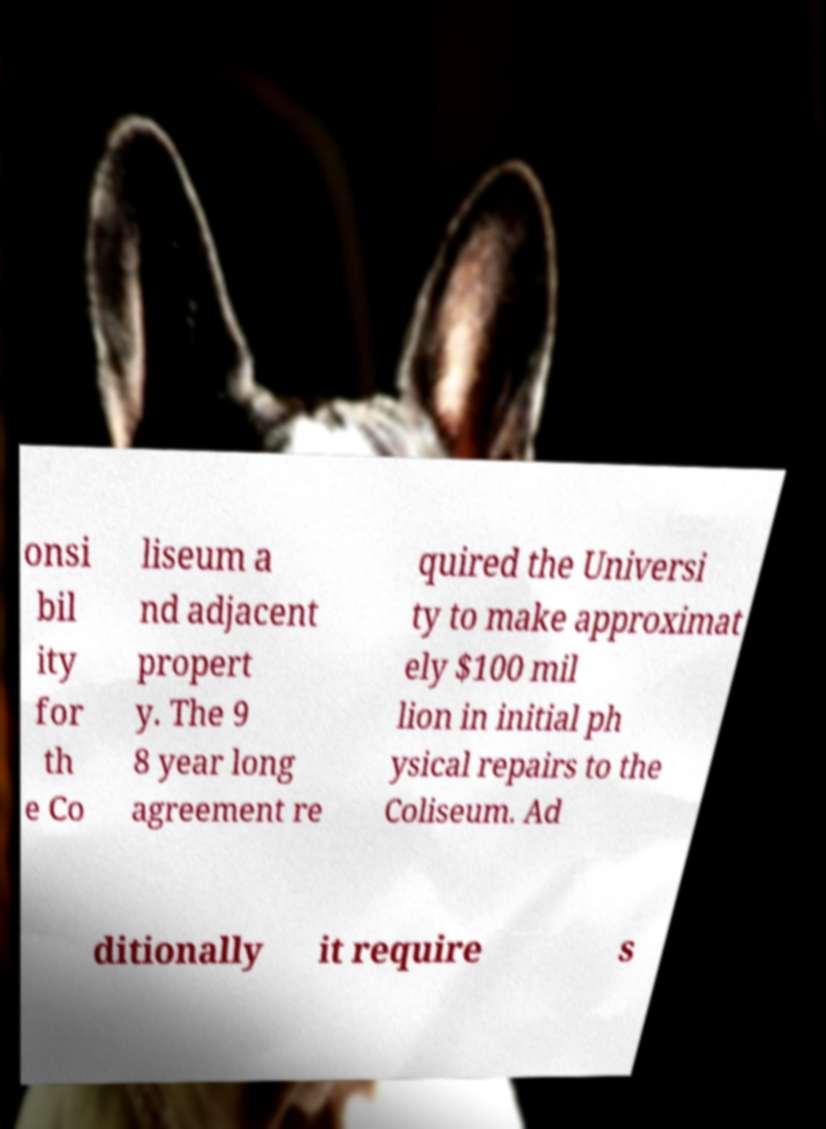Please identify and transcribe the text found in this image. onsi bil ity for th e Co liseum a nd adjacent propert y. The 9 8 year long agreement re quired the Universi ty to make approximat ely $100 mil lion in initial ph ysical repairs to the Coliseum. Ad ditionally it require s 